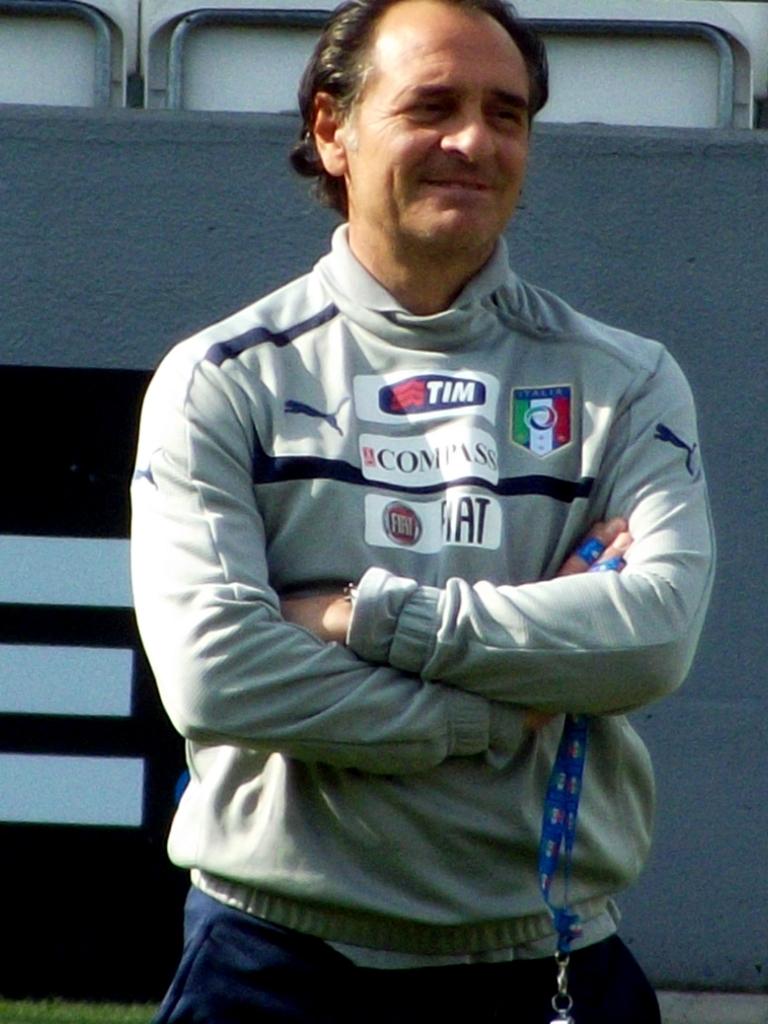Is the word fiat on the front of this man's shirt?
Offer a terse response. Yes. 